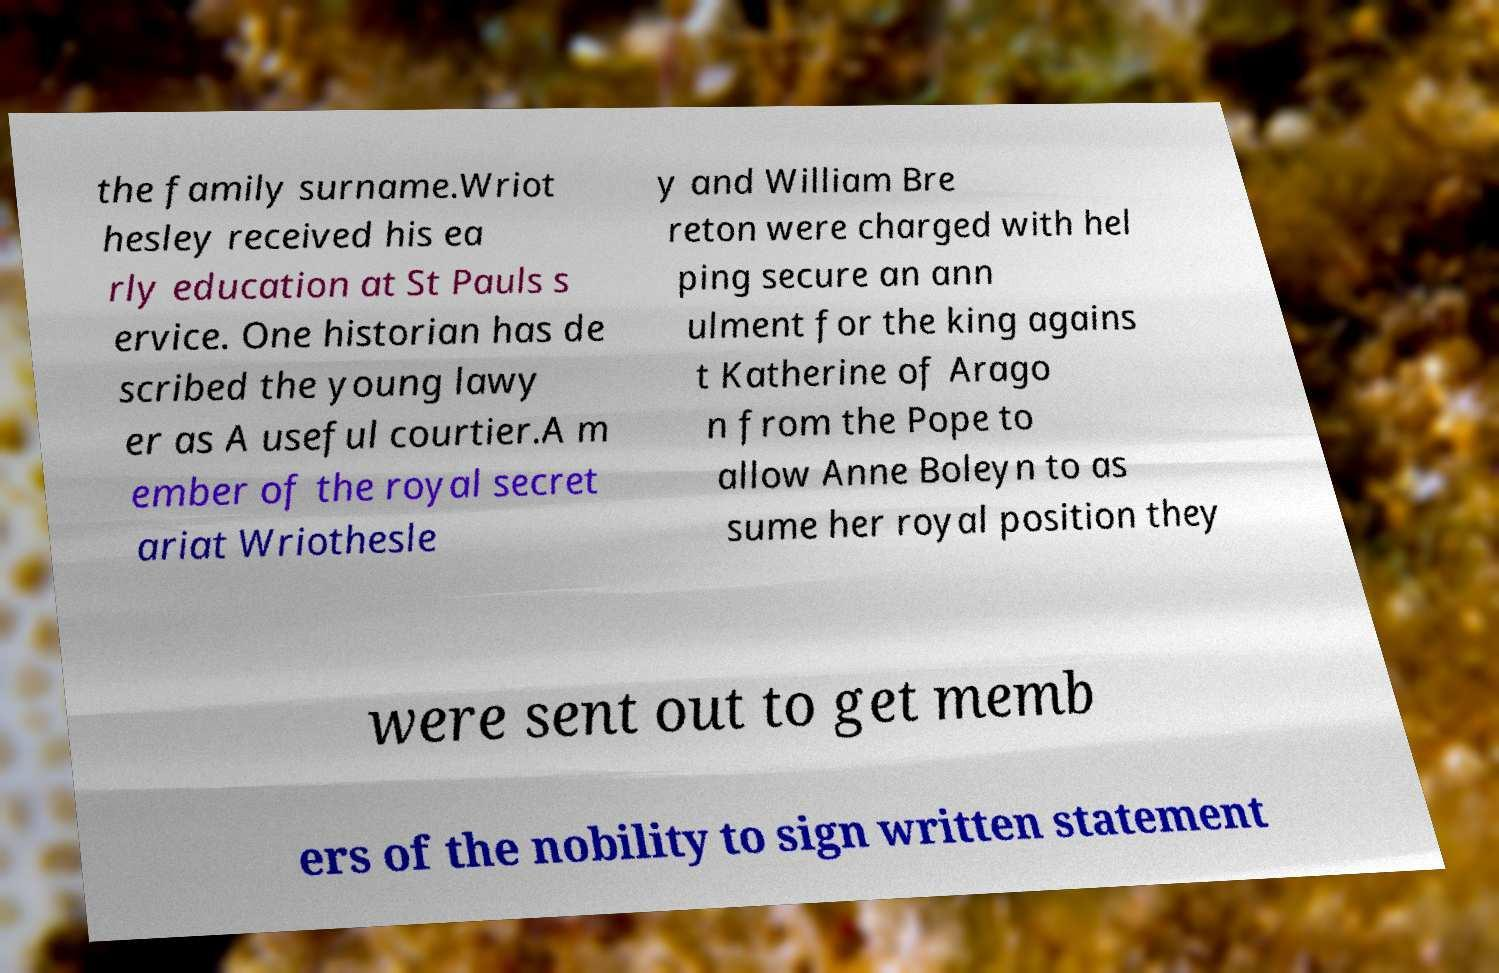Could you assist in decoding the text presented in this image and type it out clearly? the family surname.Wriot hesley received his ea rly education at St Pauls s ervice. One historian has de scribed the young lawy er as A useful courtier.A m ember of the royal secret ariat Wriothesle y and William Bre reton were charged with hel ping secure an ann ulment for the king agains t Katherine of Arago n from the Pope to allow Anne Boleyn to as sume her royal position they were sent out to get memb ers of the nobility to sign written statement 